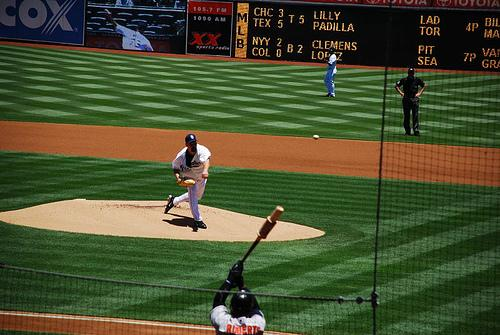Who conducts baseball league?

Choices:
A) mlb
B) iit
C) tts
D) nht mlb 